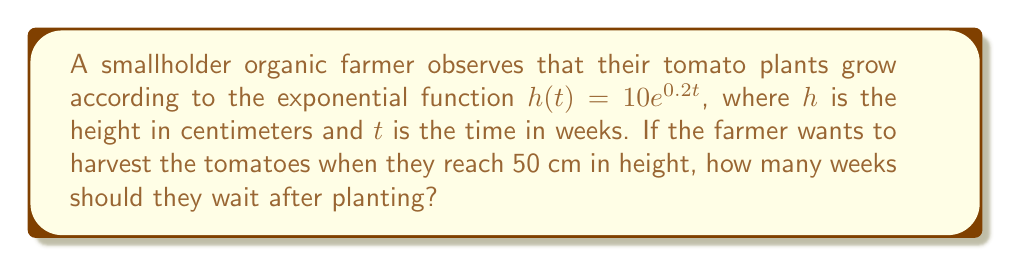Help me with this question. To solve this problem, we need to use the given exponential function and solve for $t$ when $h(t) = 50$ cm.

Step 1: Set up the equation
$$50 = 10e^{0.2t}$$

Step 2: Divide both sides by 10
$$5 = e^{0.2t}$$

Step 3: Take the natural logarithm of both sides
$$\ln(5) = \ln(e^{0.2t})$$

Step 4: Simplify the right-hand side using the property of logarithms
$$\ln(5) = 0.2t$$

Step 5: Solve for $t$
$$t = \frac{\ln(5)}{0.2}$$

Step 6: Calculate the result
$$t \approx 8.047 \text{ weeks}$$

Since we can't harvest partial weeks, we round up to the nearest whole number.
Answer: 9 weeks 